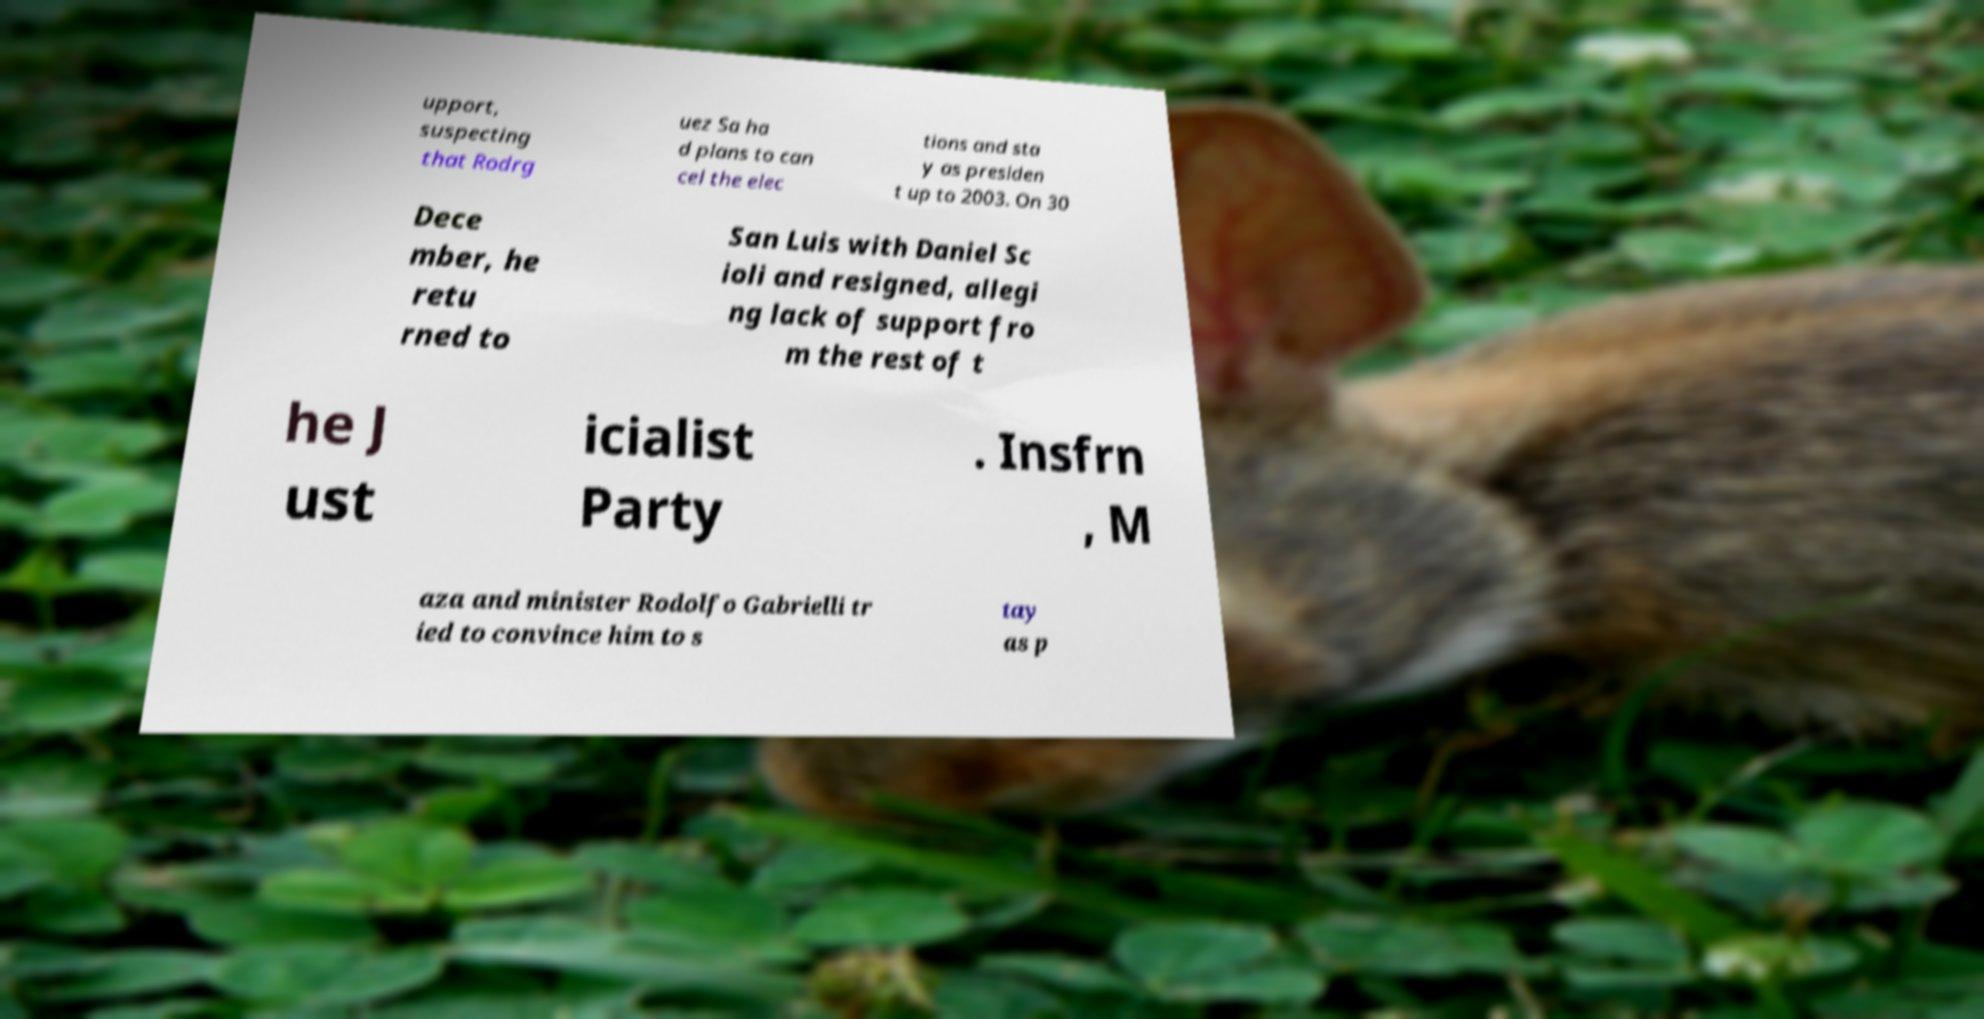Could you extract and type out the text from this image? upport, suspecting that Rodrg uez Sa ha d plans to can cel the elec tions and sta y as presiden t up to 2003. On 30 Dece mber, he retu rned to San Luis with Daniel Sc ioli and resigned, allegi ng lack of support fro m the rest of t he J ust icialist Party . Insfrn , M aza and minister Rodolfo Gabrielli tr ied to convince him to s tay as p 